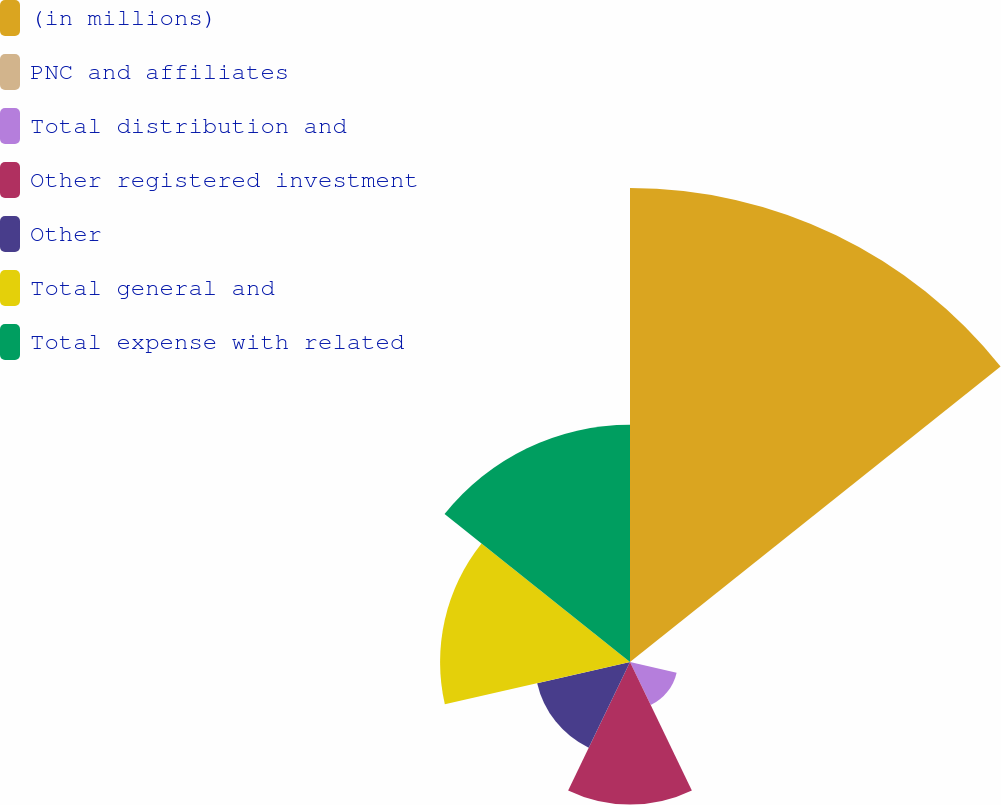Convert chart. <chart><loc_0><loc_0><loc_500><loc_500><pie_chart><fcel>(in millions)<fcel>PNC and affiliates<fcel>Total distribution and<fcel>Other registered investment<fcel>Other<fcel>Total general and<fcel>Total expense with related<nl><fcel>39.93%<fcel>0.04%<fcel>4.03%<fcel>12.01%<fcel>8.02%<fcel>16.0%<fcel>19.98%<nl></chart> 